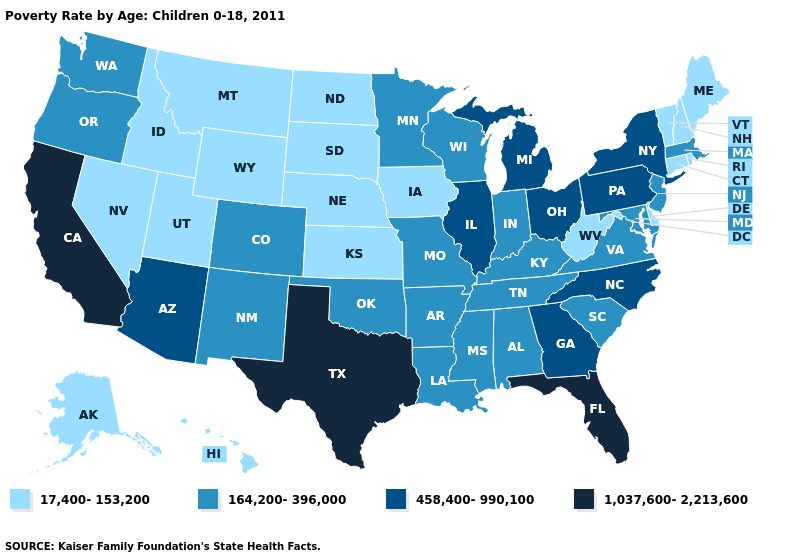Does Connecticut have a lower value than Idaho?
Keep it brief. No. Does South Dakota have the lowest value in the USA?
Write a very short answer. Yes. Name the states that have a value in the range 458,400-990,100?
Answer briefly. Arizona, Georgia, Illinois, Michigan, New York, North Carolina, Ohio, Pennsylvania. What is the lowest value in the Northeast?
Quick response, please. 17,400-153,200. What is the highest value in the USA?
Short answer required. 1,037,600-2,213,600. What is the highest value in states that border Nebraska?
Be succinct. 164,200-396,000. Does Rhode Island have the highest value in the USA?
Quick response, please. No. Does Tennessee have the lowest value in the USA?
Keep it brief. No. What is the value of South Carolina?
Keep it brief. 164,200-396,000. Name the states that have a value in the range 164,200-396,000?
Give a very brief answer. Alabama, Arkansas, Colorado, Indiana, Kentucky, Louisiana, Maryland, Massachusetts, Minnesota, Mississippi, Missouri, New Jersey, New Mexico, Oklahoma, Oregon, South Carolina, Tennessee, Virginia, Washington, Wisconsin. Does Florida have a higher value than Colorado?
Quick response, please. Yes. Does North Dakota have the same value as California?
Give a very brief answer. No. What is the lowest value in the USA?
Concise answer only. 17,400-153,200. Does California have the same value as Georgia?
Be succinct. No. What is the lowest value in the Northeast?
Give a very brief answer. 17,400-153,200. 